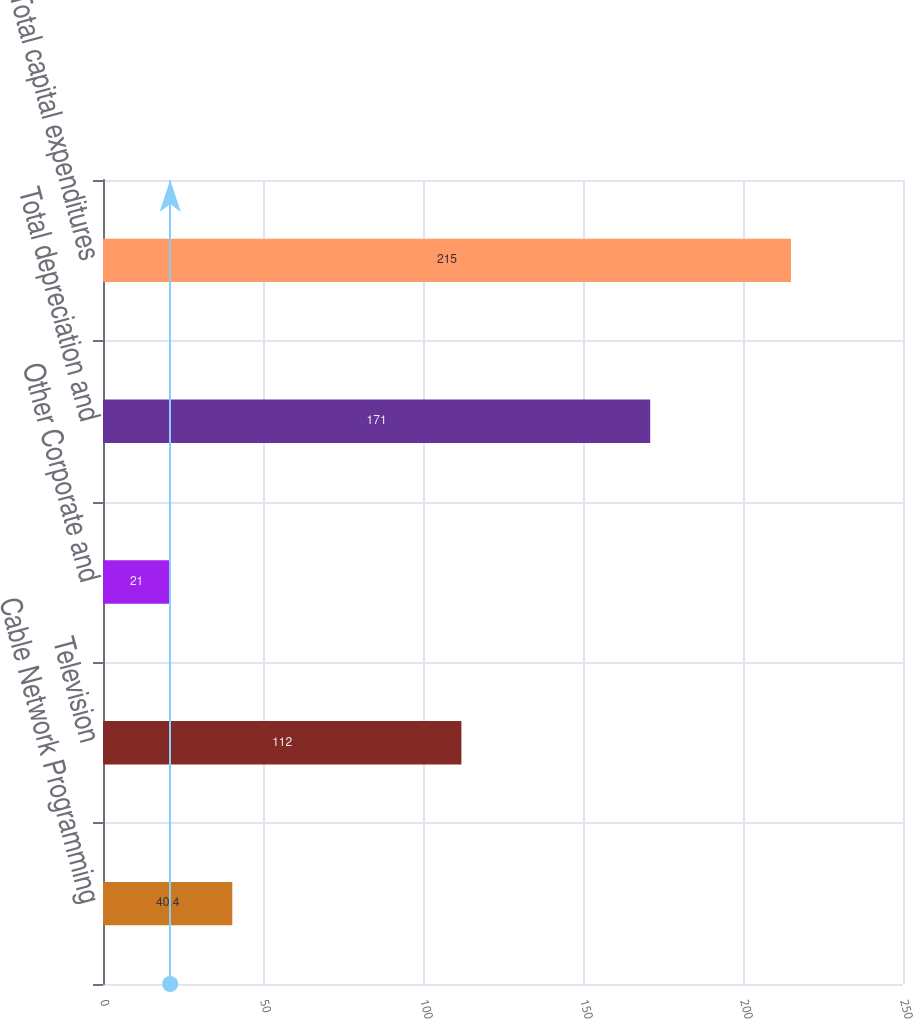Convert chart to OTSL. <chart><loc_0><loc_0><loc_500><loc_500><bar_chart><fcel>Cable Network Programming<fcel>Television<fcel>Other Corporate and<fcel>Total depreciation and<fcel>Total capital expenditures<nl><fcel>40.4<fcel>112<fcel>21<fcel>171<fcel>215<nl></chart> 